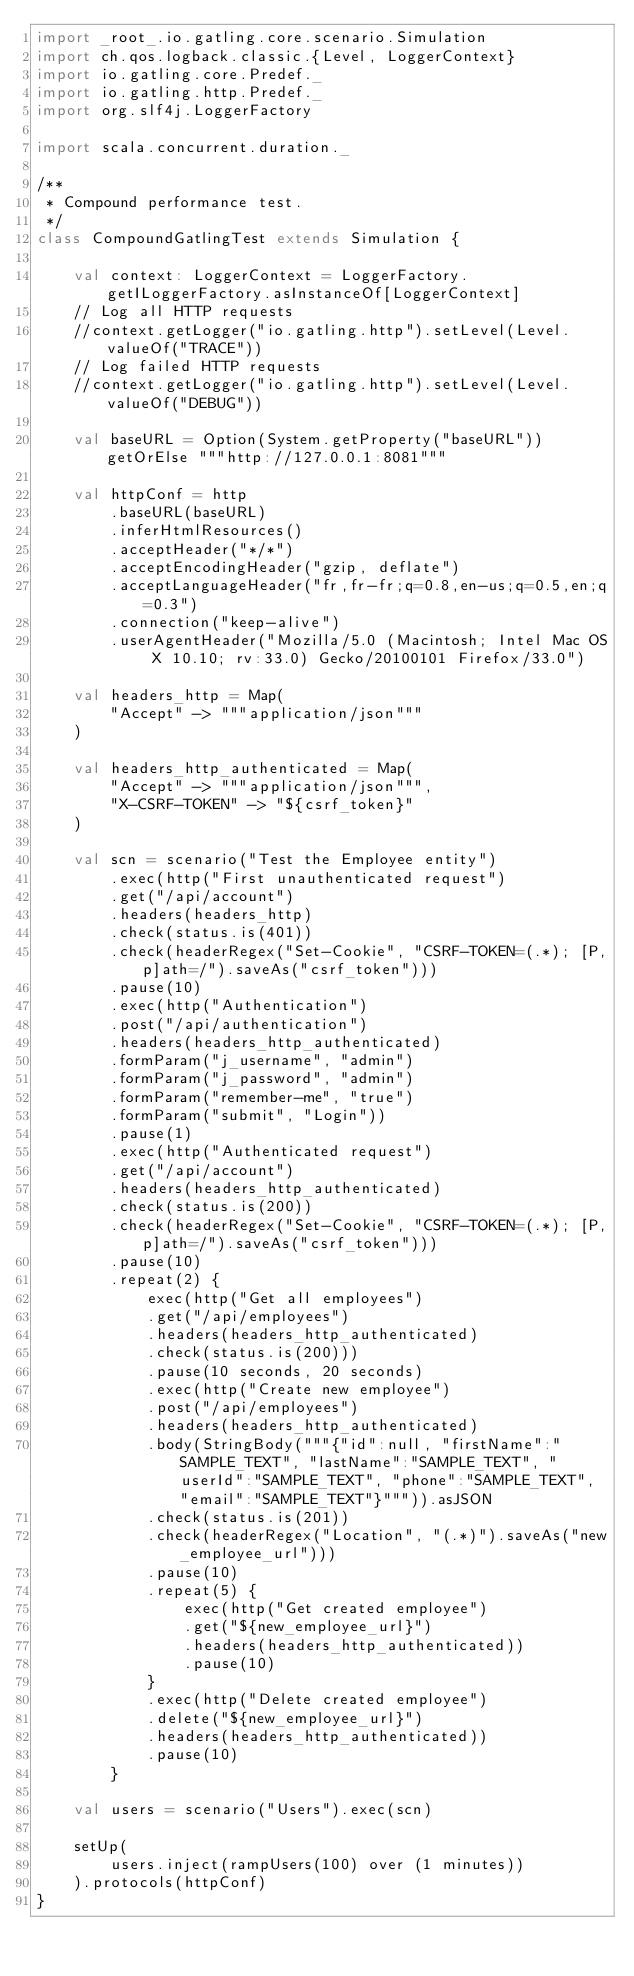Convert code to text. <code><loc_0><loc_0><loc_500><loc_500><_Scala_>import _root_.io.gatling.core.scenario.Simulation
import ch.qos.logback.classic.{Level, LoggerContext}
import io.gatling.core.Predef._
import io.gatling.http.Predef._
import org.slf4j.LoggerFactory

import scala.concurrent.duration._

/**
 * Compound performance test.
 */
class CompoundGatlingTest extends Simulation {

    val context: LoggerContext = LoggerFactory.getILoggerFactory.asInstanceOf[LoggerContext]
    // Log all HTTP requests
    //context.getLogger("io.gatling.http").setLevel(Level.valueOf("TRACE"))
    // Log failed HTTP requests
    //context.getLogger("io.gatling.http").setLevel(Level.valueOf("DEBUG"))

    val baseURL = Option(System.getProperty("baseURL")) getOrElse """http://127.0.0.1:8081"""

    val httpConf = http
        .baseURL(baseURL)
        .inferHtmlResources()
        .acceptHeader("*/*")
        .acceptEncodingHeader("gzip, deflate")
        .acceptLanguageHeader("fr,fr-fr;q=0.8,en-us;q=0.5,en;q=0.3")
        .connection("keep-alive")
        .userAgentHeader("Mozilla/5.0 (Macintosh; Intel Mac OS X 10.10; rv:33.0) Gecko/20100101 Firefox/33.0")

    val headers_http = Map(
        "Accept" -> """application/json"""
    )

    val headers_http_authenticated = Map(
        "Accept" -> """application/json""",
        "X-CSRF-TOKEN" -> "${csrf_token}"
    )

    val scn = scenario("Test the Employee entity")
        .exec(http("First unauthenticated request")
        .get("/api/account")
        .headers(headers_http)
        .check(status.is(401))
        .check(headerRegex("Set-Cookie", "CSRF-TOKEN=(.*); [P,p]ath=/").saveAs("csrf_token")))
        .pause(10)
        .exec(http("Authentication")
        .post("/api/authentication")
        .headers(headers_http_authenticated)
        .formParam("j_username", "admin")
        .formParam("j_password", "admin")
        .formParam("remember-me", "true")
        .formParam("submit", "Login"))
        .pause(1)
        .exec(http("Authenticated request")
        .get("/api/account")
        .headers(headers_http_authenticated)
        .check(status.is(200))
        .check(headerRegex("Set-Cookie", "CSRF-TOKEN=(.*); [P,p]ath=/").saveAs("csrf_token")))
        .pause(10)
        .repeat(2) {
            exec(http("Get all employees")
            .get("/api/employees")
            .headers(headers_http_authenticated)
            .check(status.is(200)))
            .pause(10 seconds, 20 seconds)
            .exec(http("Create new employee")
            .post("/api/employees")
            .headers(headers_http_authenticated)
            .body(StringBody("""{"id":null, "firstName":"SAMPLE_TEXT", "lastName":"SAMPLE_TEXT", "userId":"SAMPLE_TEXT", "phone":"SAMPLE_TEXT", "email":"SAMPLE_TEXT"}""")).asJSON
            .check(status.is(201))
            .check(headerRegex("Location", "(.*)").saveAs("new_employee_url")))
            .pause(10)
            .repeat(5) {
                exec(http("Get created employee")
                .get("${new_employee_url}")
                .headers(headers_http_authenticated))
                .pause(10)
            }
            .exec(http("Delete created employee")
            .delete("${new_employee_url}")
            .headers(headers_http_authenticated))
            .pause(10)
        }

    val users = scenario("Users").exec(scn)

    setUp(
        users.inject(rampUsers(100) over (1 minutes))
    ).protocols(httpConf)
}
</code> 